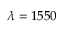<formula> <loc_0><loc_0><loc_500><loc_500>\lambda = 1 5 5 0</formula> 